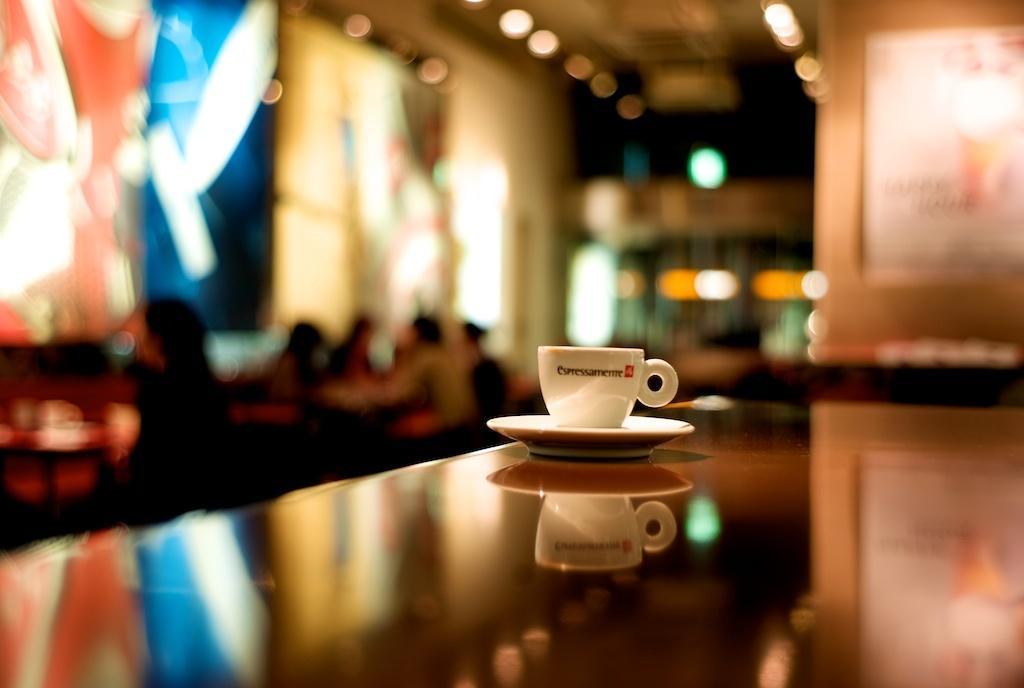In one or two sentences, can you explain what this image depicts? The coffee cup and saucer are highlighted in this picture. On this table there is a coffee cup with saucer. Far persons are sitting on chair. 